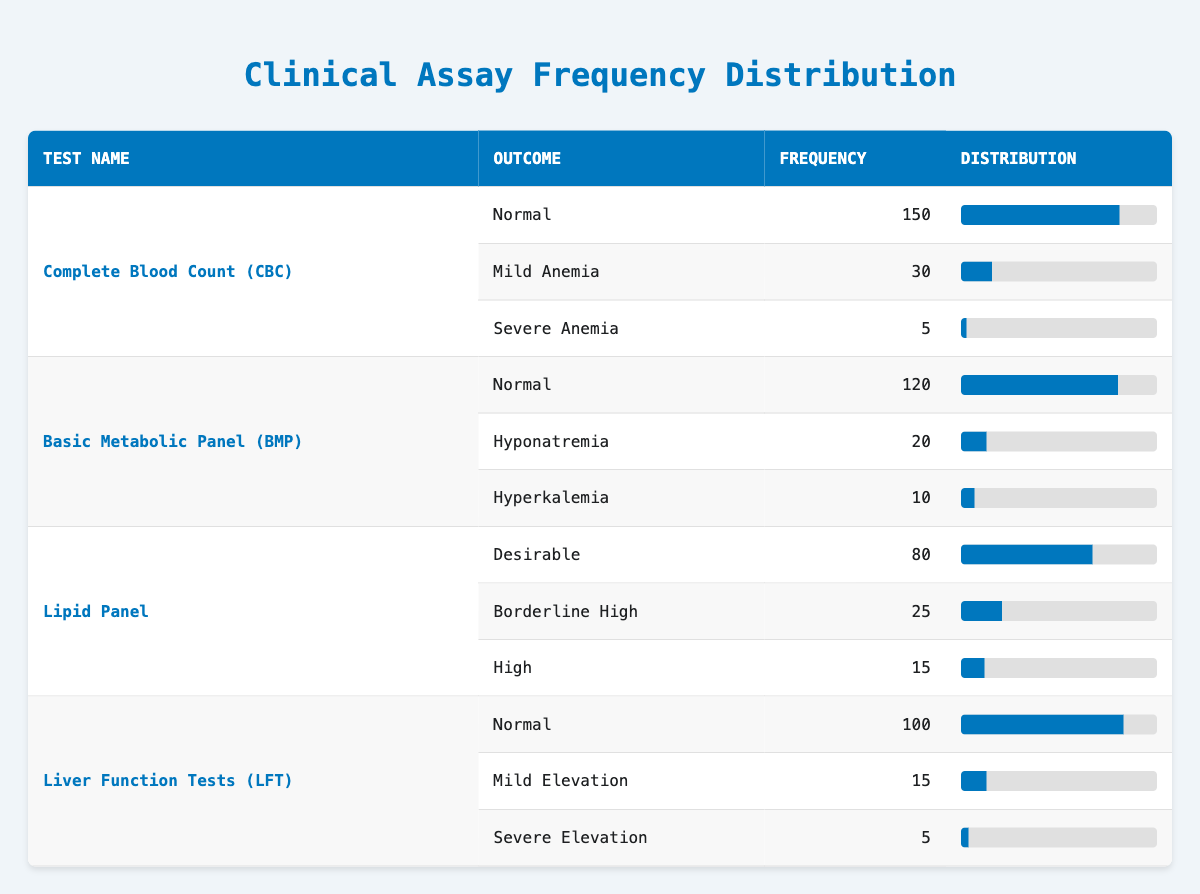What is the frequency of Severe Anemia in the Complete Blood Count test? From the table, the row for Complete Blood Count shows that the frequency of Severe Anemia is listed as 5.
Answer: 5 How many individuals showed a Normal outcome in the Basic Metabolic Panel? Referring to the Basic Metabolic Panel row in the table, it shows the frequency for Normal is 120.
Answer: 120 What is the total frequency of outcomes that indicate elevated values in the Lipid Panel? The elevated outcomes in the Lipid Panel are Borderline High (25) and High (15). Adding these gives 25 + 15 = 40.
Answer: 40 Is it true that the Complete Blood Count has the highest frequency for any outcome? Looking at the frequencies, Complete Blood Count has 150 for Normal, which is the highest compared to other test outcomes. Therefore, it is true.
Answer: Yes What is the average frequency of outcomes for the Liver Function Tests? The frequencies for Liver Function Tests are 100 (Normal), 15 (Mild Elevation), and 5 (Severe Elevation). The total is 100 + 15 + 5 = 120, and there are 3 outcomes, so the average is 120 / 3 = 40.
Answer: 40 Which test result has the least frequency recorded, and what is that frequency? The least frequency in the table is for Severe Anemia (5) and Severe Elevation (5) for different test results. Both have the same frequency.
Answer: 5 What percentage of tests in the Lipid Panel were classified as Desirable? The total frequency for Lipid Panel is 80 (Desirable) + 25 (Borderline High) + 15 (High) = 120. The percentage for Desirable is (80 / 120) * 100 = 66.67%.
Answer: 66.67% If we combine the frequencies of Mild Anemia and Mild Elevation, what is the total? The frequency of Mild Anemia in Complete Blood Count is 30, and the frequency of Mild Elevation in Liver Function Tests is 15. Adding these gives us 30 + 15 = 45.
Answer: 45 What is the frequency of people who showed Hyponatremia in the Basic Metabolic Panel? Referring to the Basic Metabolic Panel section of the table, the frequency of individuals with Hyponatremia is recorded as 20.
Answer: 20 